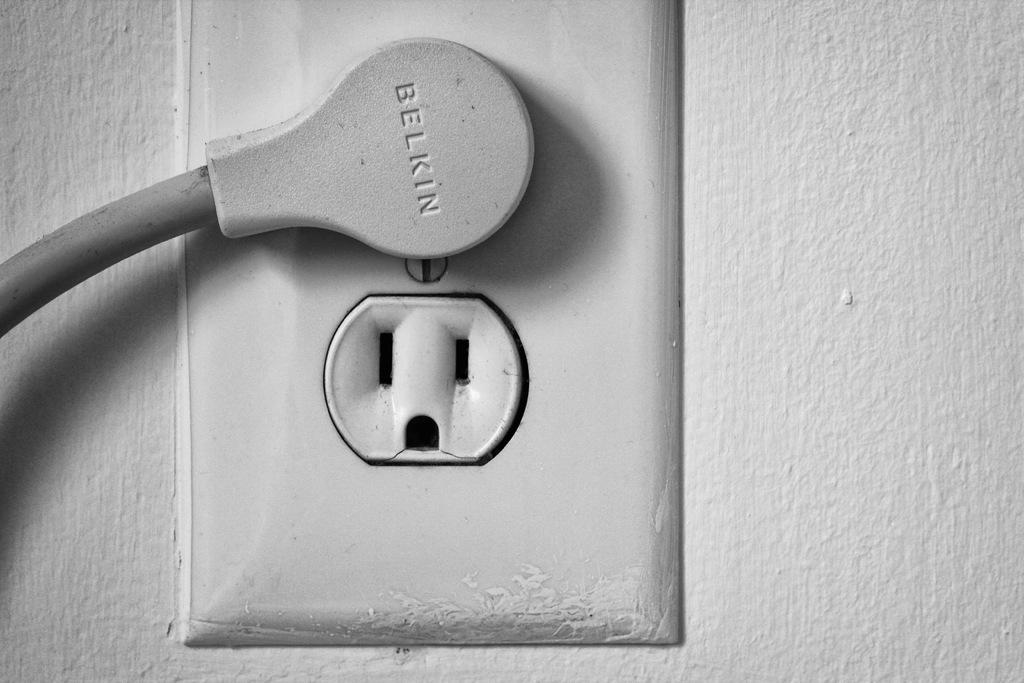<image>
Give a short and clear explanation of the subsequent image. A plug on the wall, the plug is by Belkin and is gray. 